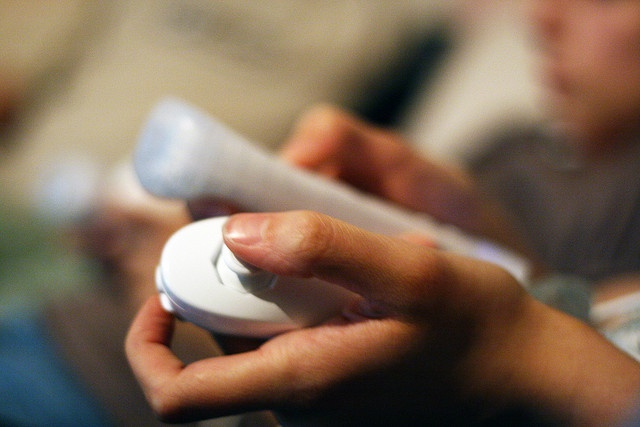Describe the objects in this image and their specific colors. I can see people in tan, black, maroon, and brown tones, people in tan, black, maroon, and brown tones, remote in tan, darkgray, and lightgray tones, and remote in tan, white, maroon, gray, and black tones in this image. 